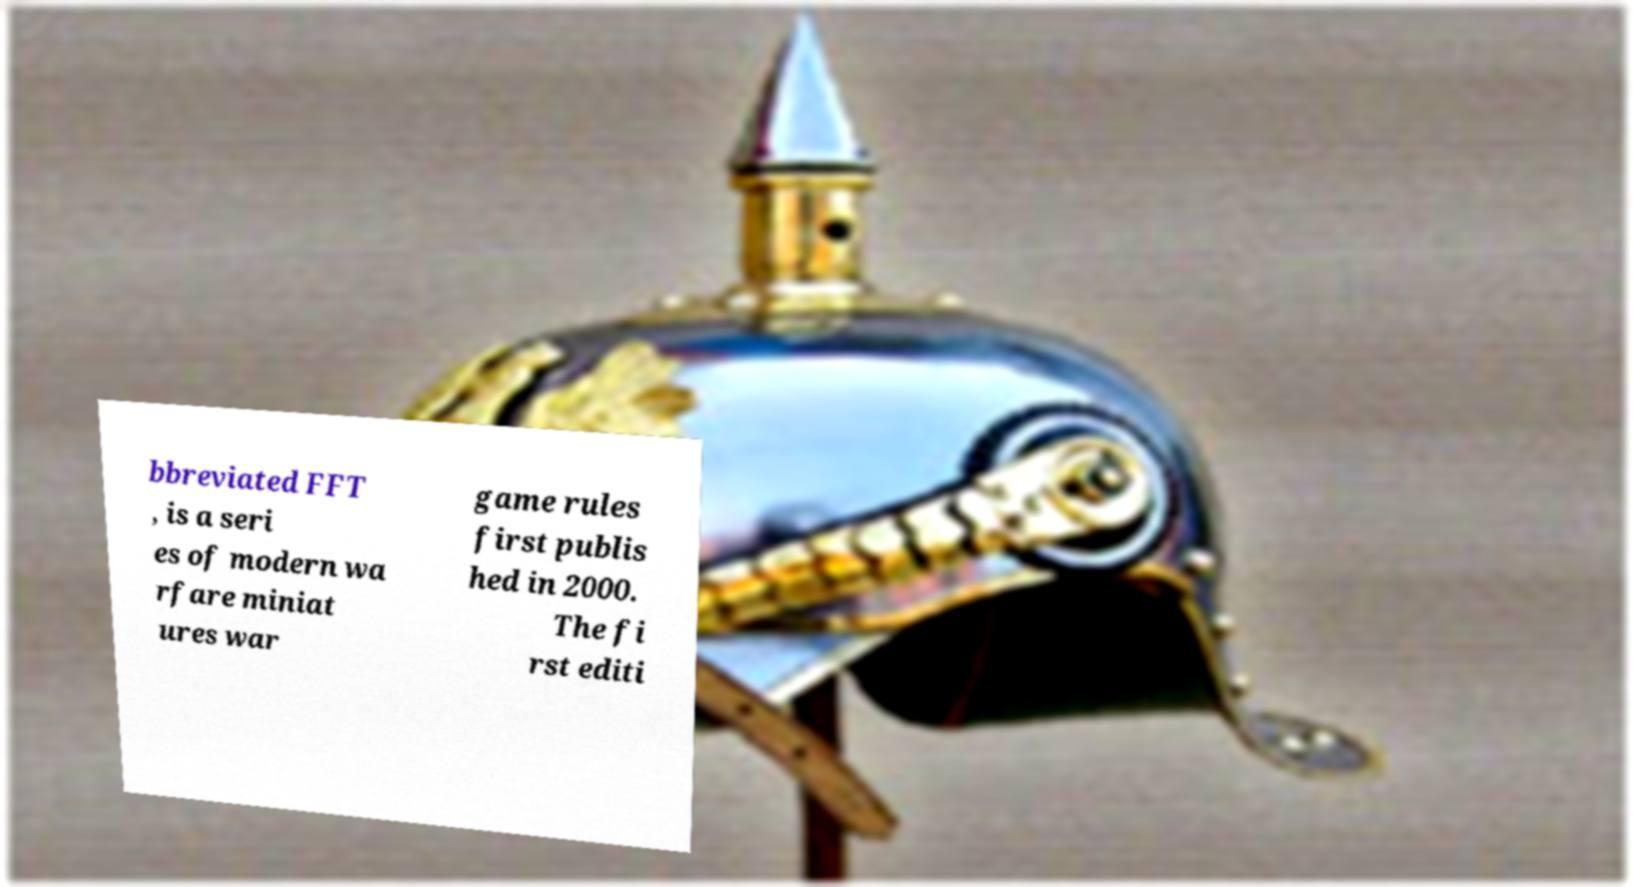Could you assist in decoding the text presented in this image and type it out clearly? bbreviated FFT , is a seri es of modern wa rfare miniat ures war game rules first publis hed in 2000. The fi rst editi 